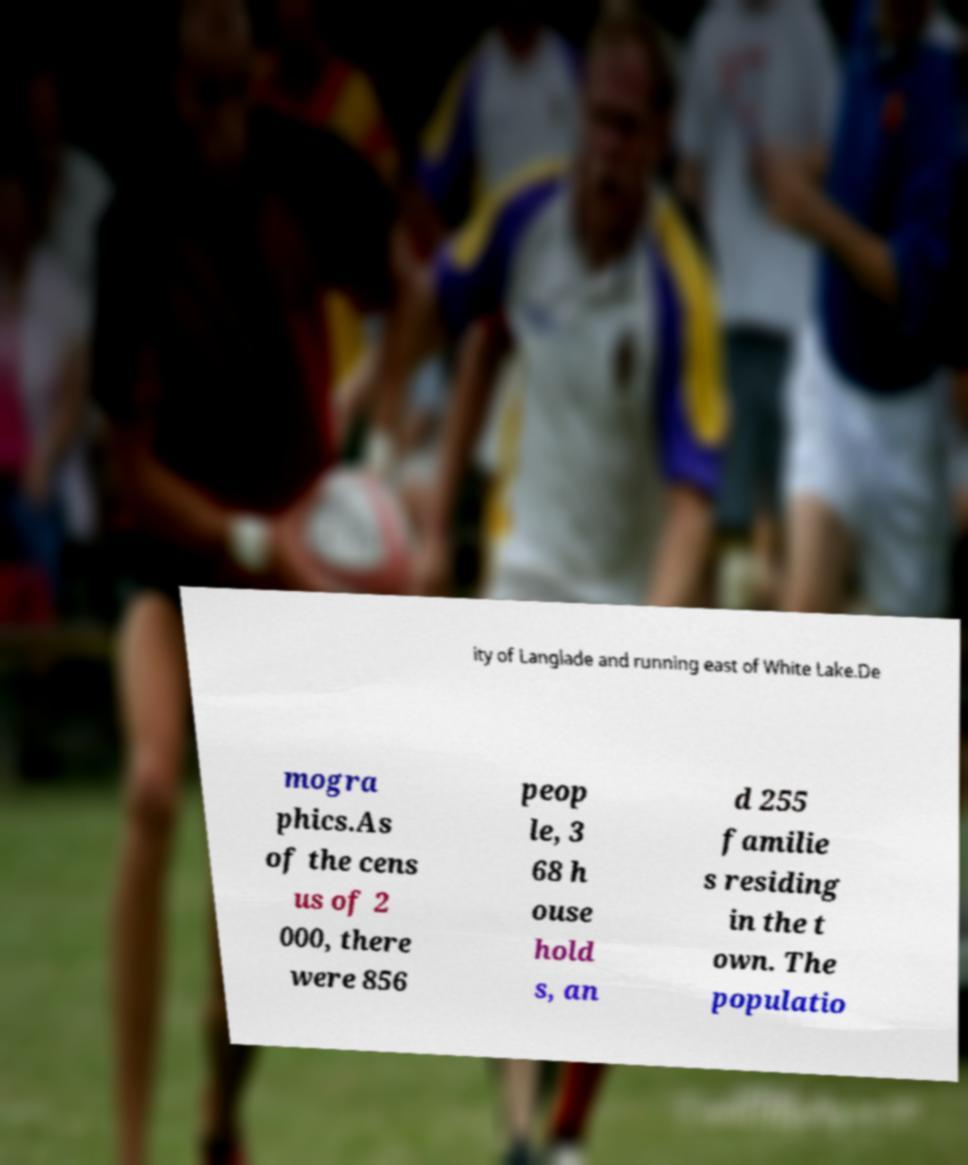Please read and relay the text visible in this image. What does it say? ity of Langlade and running east of White Lake.De mogra phics.As of the cens us of 2 000, there were 856 peop le, 3 68 h ouse hold s, an d 255 familie s residing in the t own. The populatio 